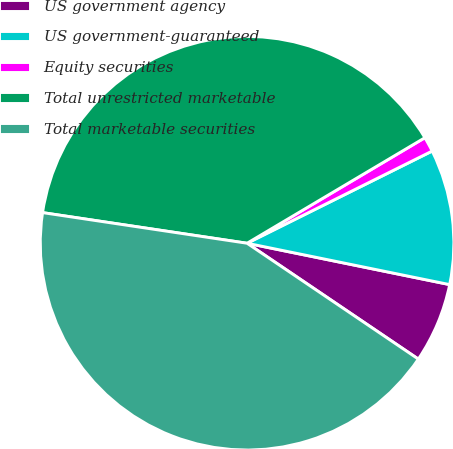Convert chart to OTSL. <chart><loc_0><loc_0><loc_500><loc_500><pie_chart><fcel>US government agency<fcel>US government-guaranteed<fcel>Equity securities<fcel>Total unrestricted marketable<fcel>Total marketable securities<nl><fcel>6.26%<fcel>10.56%<fcel>1.17%<fcel>39.11%<fcel>42.9%<nl></chart> 